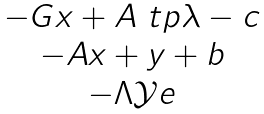<formula> <loc_0><loc_0><loc_500><loc_500>\begin{matrix} - G x + A ^ { \ } t p \lambda - c \\ - A x + y + b \\ - \Lambda \mathcal { Y } e \end{matrix}</formula> 